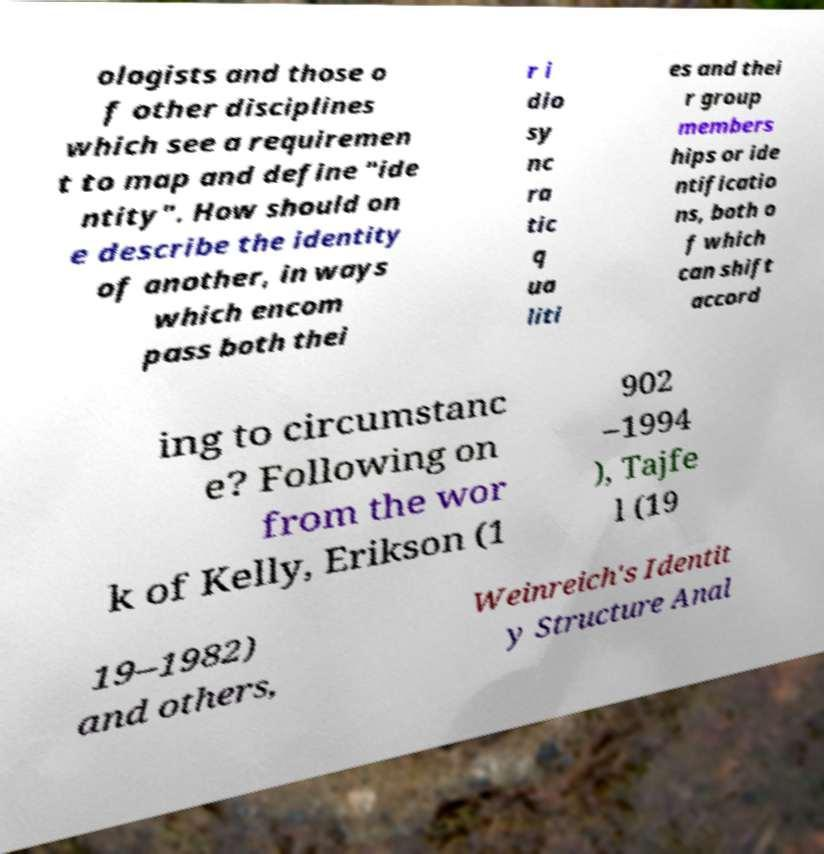Can you read and provide the text displayed in the image?This photo seems to have some interesting text. Can you extract and type it out for me? ologists and those o f other disciplines which see a requiremen t to map and define "ide ntity". How should on e describe the identity of another, in ways which encom pass both thei r i dio sy nc ra tic q ua liti es and thei r group members hips or ide ntificatio ns, both o f which can shift accord ing to circumstanc e? Following on from the wor k of Kelly, Erikson (1 902 –1994 ), Tajfe l (19 19–1982) and others, Weinreich's Identit y Structure Anal 